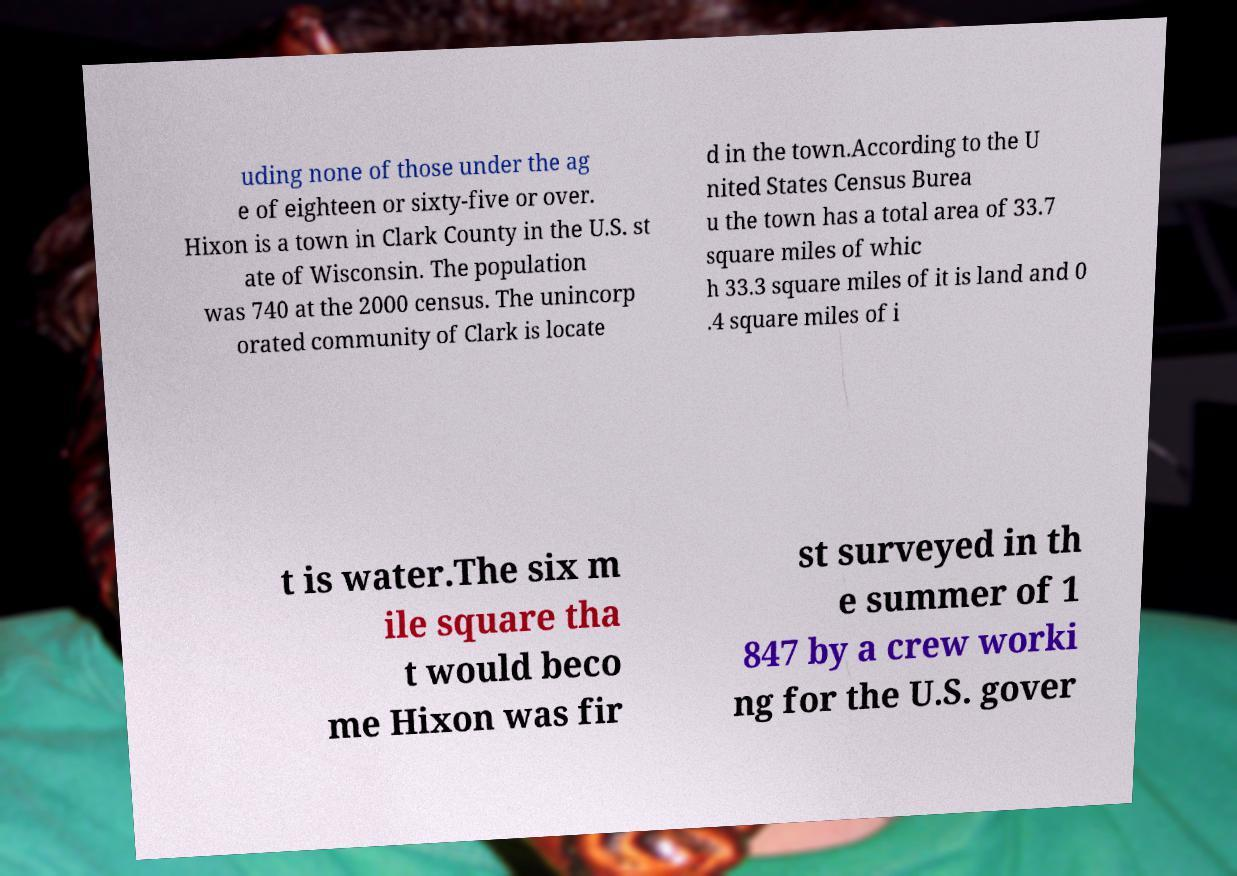What messages or text are displayed in this image? I need them in a readable, typed format. uding none of those under the ag e of eighteen or sixty-five or over. Hixon is a town in Clark County in the U.S. st ate of Wisconsin. The population was 740 at the 2000 census. The unincorp orated community of Clark is locate d in the town.According to the U nited States Census Burea u the town has a total area of 33.7 square miles of whic h 33.3 square miles of it is land and 0 .4 square miles of i t is water.The six m ile square tha t would beco me Hixon was fir st surveyed in th e summer of 1 847 by a crew worki ng for the U.S. gover 